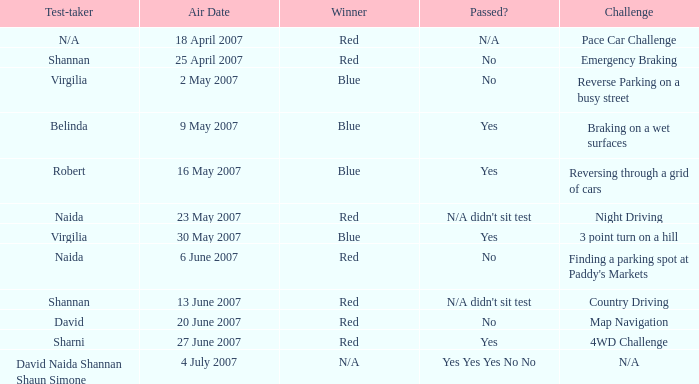On which air date was Robert the test-taker? 16 May 2007. 